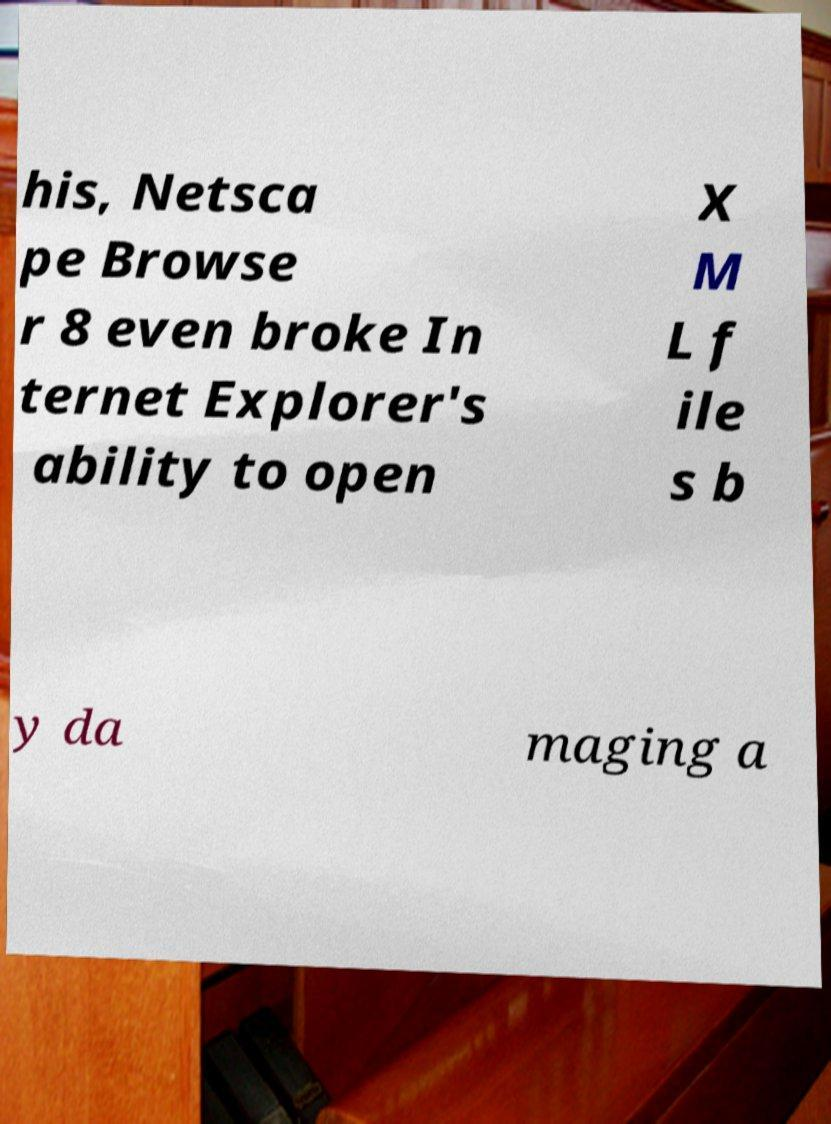I need the written content from this picture converted into text. Can you do that? his, Netsca pe Browse r 8 even broke In ternet Explorer's ability to open X M L f ile s b y da maging a 